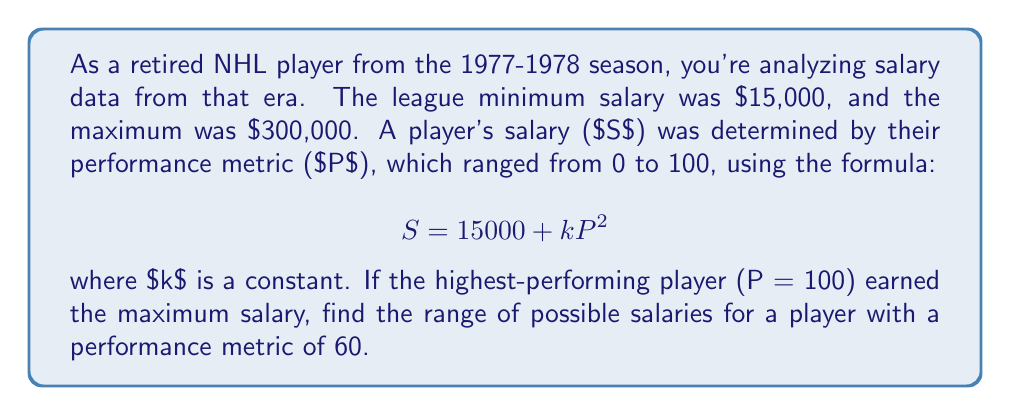Give your solution to this math problem. Let's approach this step-by-step:

1) First, we need to find the value of $k$. We can do this using the maximum salary information:

   $$ 300000 = 15000 + k(100)^2 $$
   $$ 285000 = 10000k $$
   $$ k = 28.5 $$

2) Now that we know $k$, we can write the full salary formula:

   $$ S = 15000 + 28.5P^2 $$

3) For a player with a performance metric of 60, we can calculate their salary:

   $$ S = 15000 + 28.5(60)^2 $$
   $$ S = 15000 + 28.5(3600) $$
   $$ S = 15000 + 102600 $$
   $$ S = 117600 $$

4) However, this assumes that the $k$ value is the same for all players. In reality, it could be lower, but not higher (as that would exceed the maximum salary for top performers).

5) The minimum possible salary for this player would be the league minimum of $15,000.

6) Therefore, the range of possible salaries is from $15,000 to $117,600.
Answer: The range of possible salaries for a player with a performance metric of 60 during the 1977-1978 NHL season is $[$15000, $117600]$. 